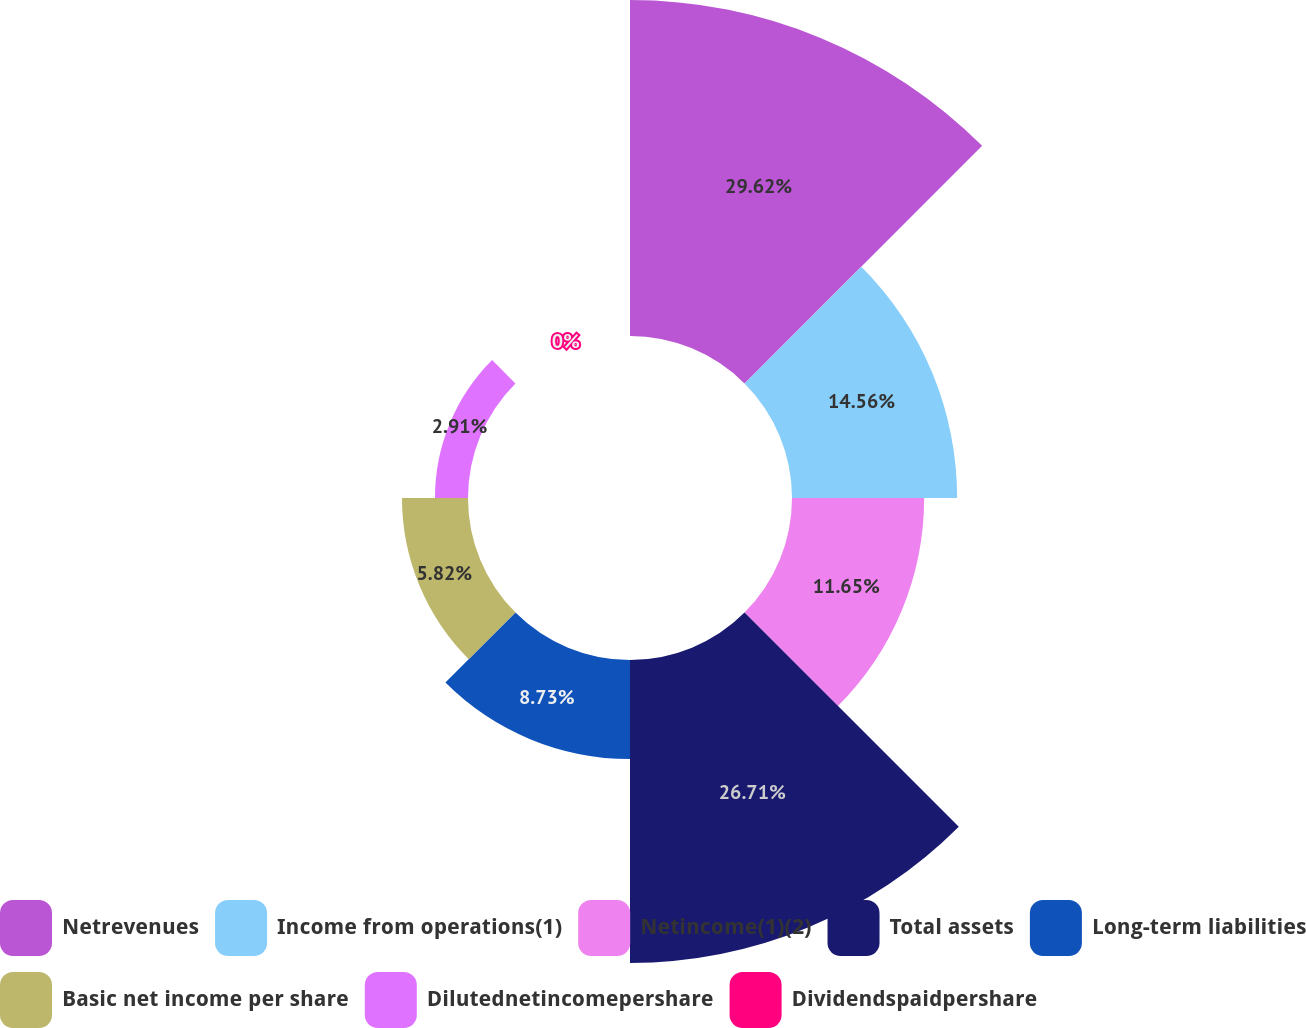<chart> <loc_0><loc_0><loc_500><loc_500><pie_chart><fcel>Netrevenues<fcel>Income from operations(1)<fcel>Netincome(1)(2)<fcel>Total assets<fcel>Long-term liabilities<fcel>Basic net income per share<fcel>Dilutednetincomepershare<fcel>Dividendspaidpershare<nl><fcel>29.62%<fcel>14.56%<fcel>11.65%<fcel>26.71%<fcel>8.73%<fcel>5.82%<fcel>2.91%<fcel>0.0%<nl></chart> 